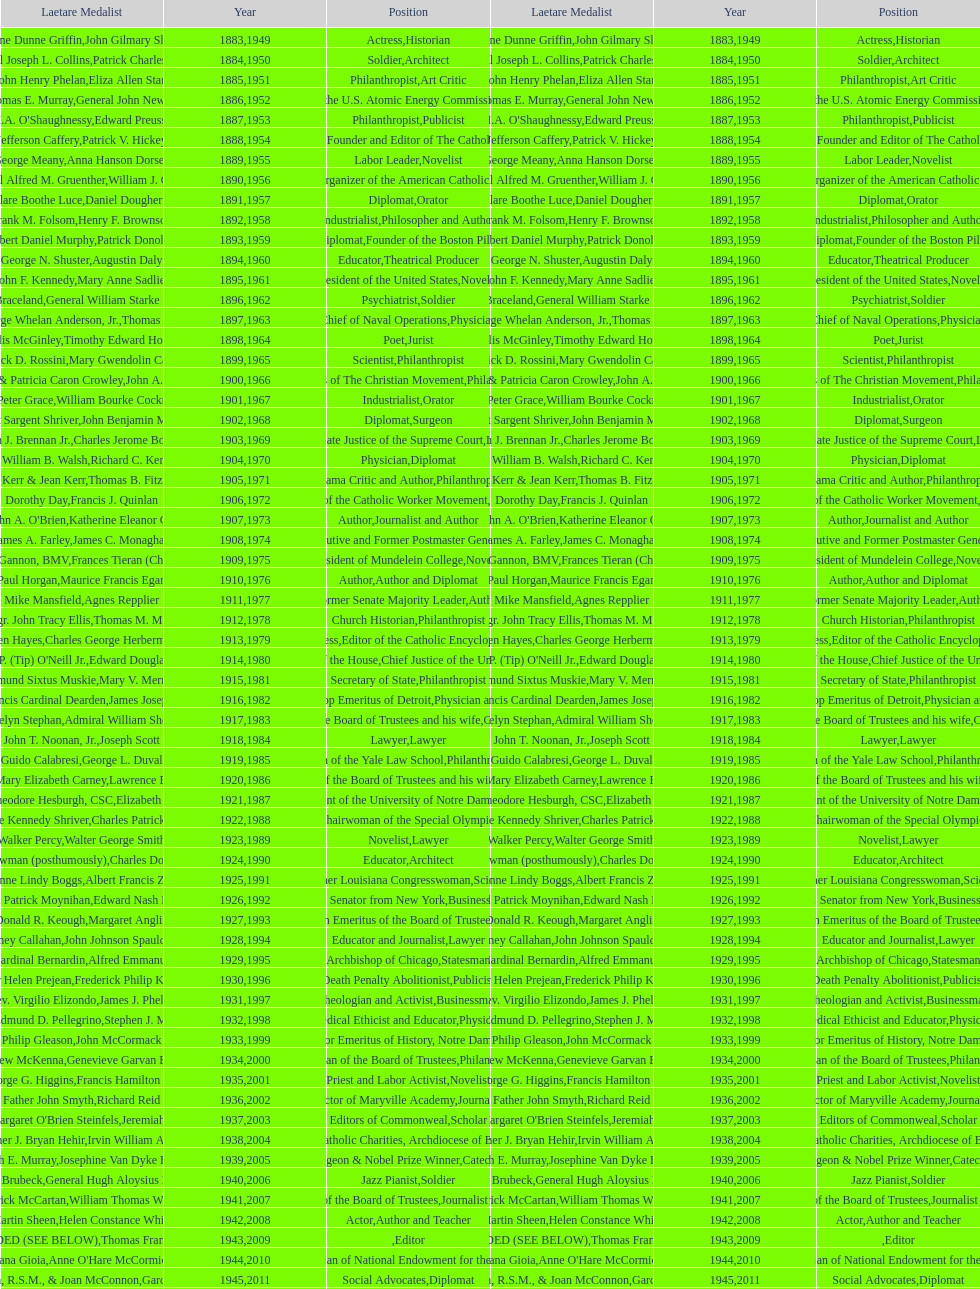How many times does philanthropist appear in the position column on this chart? 9. 